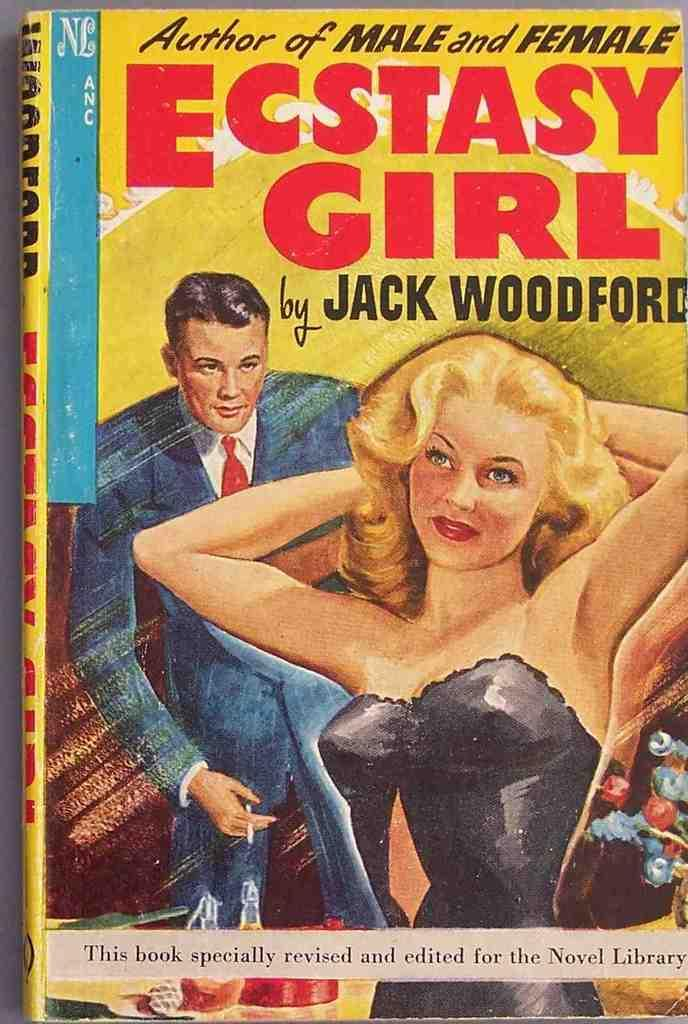<image>
Summarize the visual content of the image. A book by Jack Woodford titled Ecstasy Girl. 